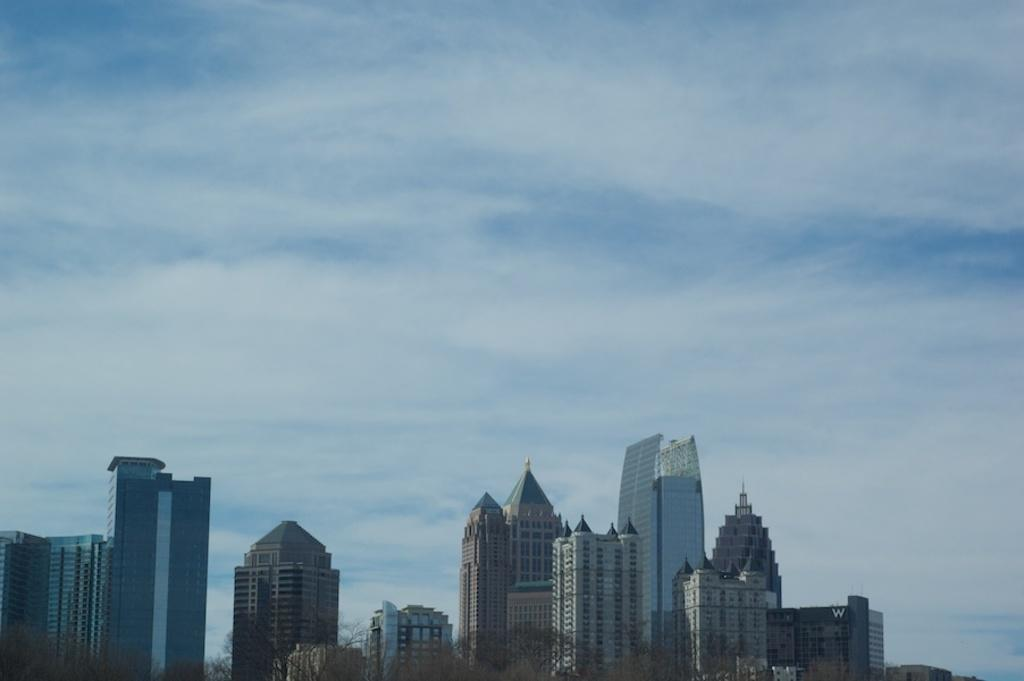What type of structures can be seen in the image? There are buildings in the image. What other natural elements are present in the image? There are trees in the image. What is visible at the top of the image? The sky is visible at the top of the image. How is the tin being distributed in the image? There is no tin present in the image, so it cannot be distributed. 